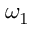<formula> <loc_0><loc_0><loc_500><loc_500>\omega _ { 1 }</formula> 